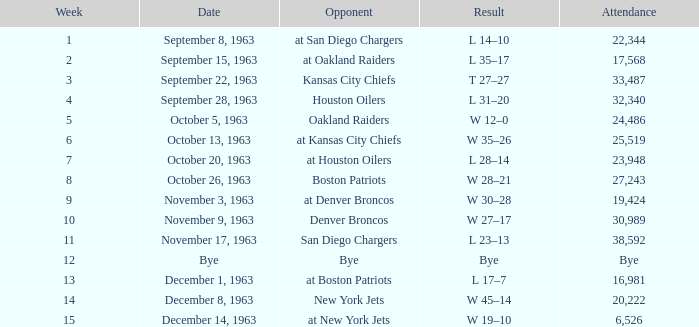For which situation is the week number under 11 and the attendance figure 17,568? L 35–17. 